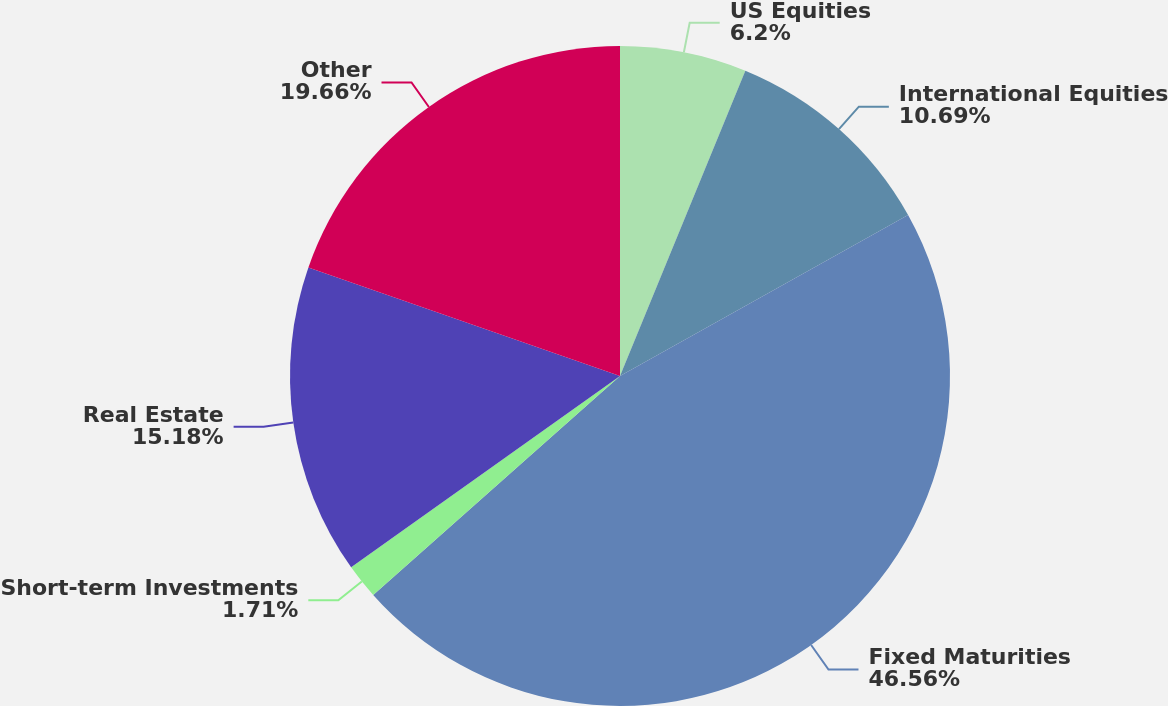<chart> <loc_0><loc_0><loc_500><loc_500><pie_chart><fcel>US Equities<fcel>International Equities<fcel>Fixed Maturities<fcel>Short-term Investments<fcel>Real Estate<fcel>Other<nl><fcel>6.2%<fcel>10.69%<fcel>46.55%<fcel>1.71%<fcel>15.18%<fcel>19.66%<nl></chart> 